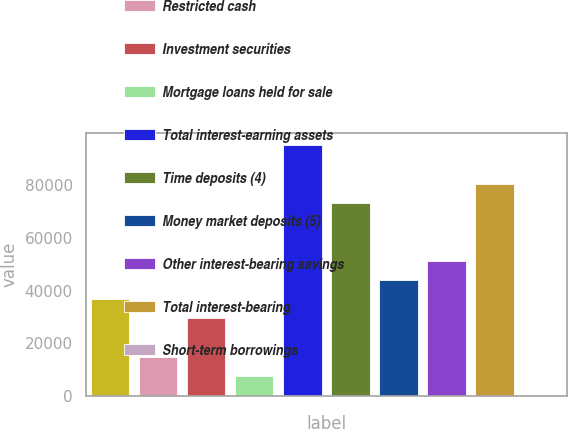<chart> <loc_0><loc_0><loc_500><loc_500><bar_chart><fcel>Cash and cash equivalents<fcel>Restricted cash<fcel>Investment securities<fcel>Mortgage loans held for sale<fcel>Total interest-earning assets<fcel>Time deposits (4)<fcel>Money market deposits (5)<fcel>Other interest-bearing savings<fcel>Total interest-bearing<fcel>Short-term borrowings<nl><fcel>36735<fcel>14813.4<fcel>29427.8<fcel>7506.2<fcel>95192.6<fcel>73271<fcel>44042.2<fcel>51349.4<fcel>80578.2<fcel>199<nl></chart> 